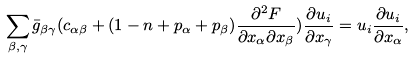Convert formula to latex. <formula><loc_0><loc_0><loc_500><loc_500>\sum _ { \beta , \gamma } \bar { g } _ { \beta \gamma } ( c _ { \alpha \beta } + ( 1 - n + p _ { \alpha } + p _ { \beta } ) \frac { \partial ^ { 2 } F } { \partial x _ { \alpha } \partial x _ { \beta } } ) \frac { \partial u _ { i } } { \partial x _ { \gamma } } = u _ { i } \frac { \partial u _ { i } } { \partial x _ { \alpha } } ,</formula> 